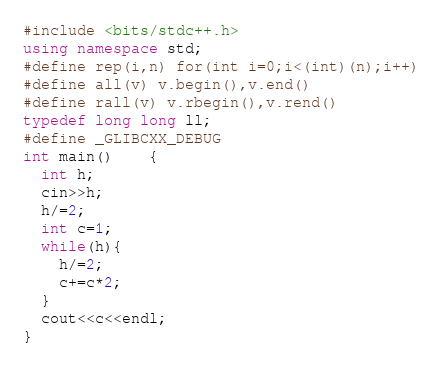Convert code to text. <code><loc_0><loc_0><loc_500><loc_500><_C++_>#include <bits/stdc++.h>
using namespace std;
#define rep(i,n) for(int i=0;i<(int)(n);i++)
#define all(v) v.begin(),v.end()
#define rall(v) v.rbegin(),v.rend()
typedef long long ll;
#define _GLIBCXX_DEBUG
int main()	{
  int h;
  cin>>h;
  h/=2;
  int c=1;
  while(h){
    h/=2;
    c+=c*2;
  }
  cout<<c<<endl;
}</code> 